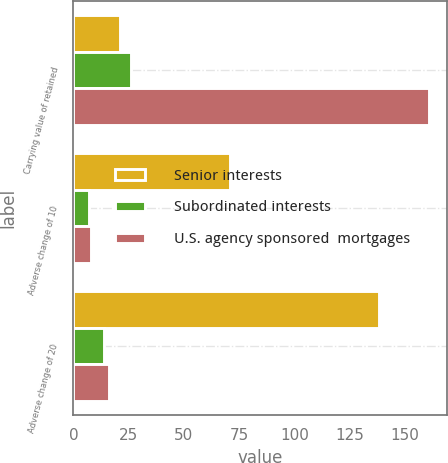Convert chart. <chart><loc_0><loc_0><loc_500><loc_500><stacked_bar_chart><ecel><fcel>Carrying value of retained<fcel>Adverse change of 10<fcel>Adverse change of 20<nl><fcel>Senior interests<fcel>21<fcel>71<fcel>138<nl><fcel>Subordinated interests<fcel>26<fcel>7<fcel>14<nl><fcel>U.S. agency sponsored  mortgages<fcel>161<fcel>8<fcel>16<nl></chart> 